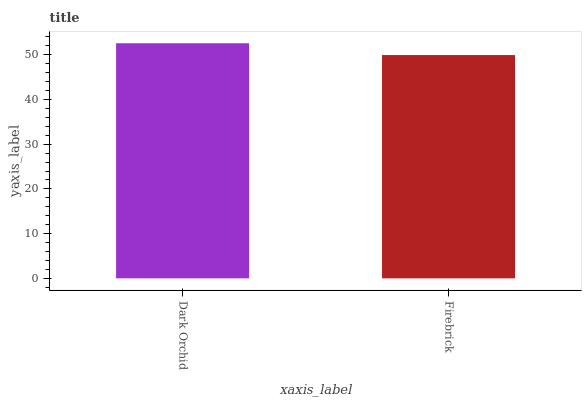Is Firebrick the minimum?
Answer yes or no. Yes. Is Dark Orchid the maximum?
Answer yes or no. Yes. Is Firebrick the maximum?
Answer yes or no. No. Is Dark Orchid greater than Firebrick?
Answer yes or no. Yes. Is Firebrick less than Dark Orchid?
Answer yes or no. Yes. Is Firebrick greater than Dark Orchid?
Answer yes or no. No. Is Dark Orchid less than Firebrick?
Answer yes or no. No. Is Dark Orchid the high median?
Answer yes or no. Yes. Is Firebrick the low median?
Answer yes or no. Yes. Is Firebrick the high median?
Answer yes or no. No. Is Dark Orchid the low median?
Answer yes or no. No. 